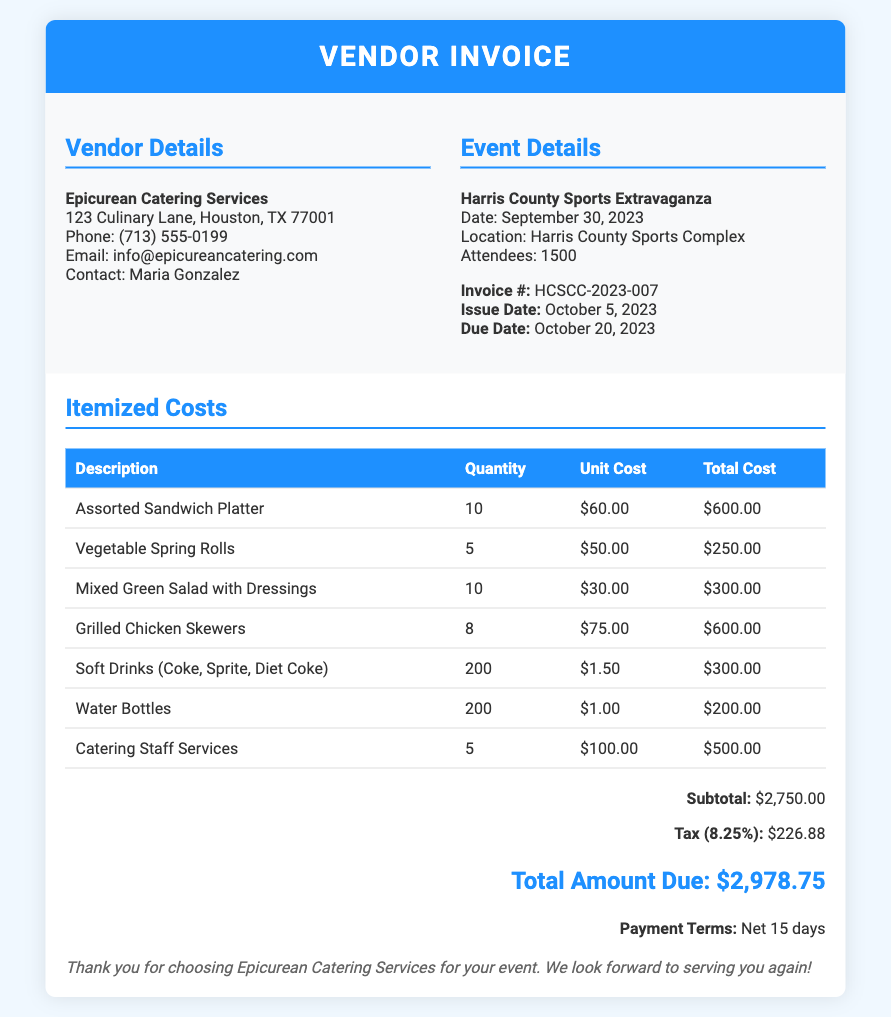What is the name of the vendor? The vendor is identified as Epicurean Catering Services in the document.
Answer: Epicurean Catering Services What is the invoice number? The invoice is labeled as HCSCC-2023-007, as mentioned in the document.
Answer: HCSCC-2023-007 What is the total amount due? The document states that the total amount due is $2,978.75.
Answer: $2,978.75 How many attendees were there at the event? The invoice indicates that there were 1500 attendees at the Harris County Sports Extravaganza.
Answer: 1500 What is the unit cost of Soft Drinks? The document lists the unit cost of Soft Drinks as $1.50.
Answer: $1.50 What is the tax percentage applied? The invoice mentions a tax percentage of 8.25%.
Answer: 8.25% When is the due date for the invoice? The due date provided in the document is October 20, 2023.
Answer: October 20, 2023 What is the subtotal before tax? The subtotal before tax is stated as $2,750.00 in the document.
Answer: $2,750.00 How many Grilled Chicken Skewers were ordered? The document indicates that 8 Grilled Chicken Skewers were ordered.
Answer: 8 